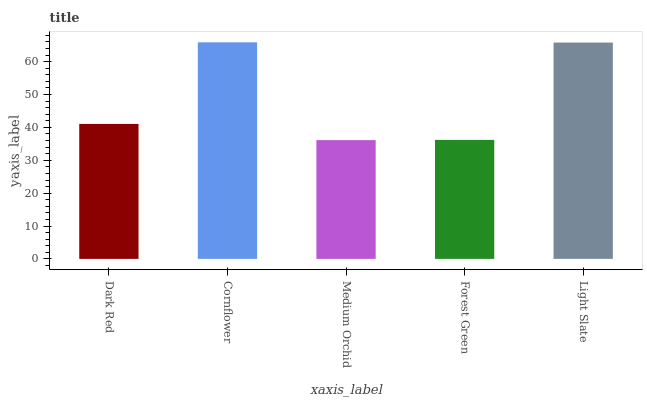Is Medium Orchid the minimum?
Answer yes or no. Yes. Is Cornflower the maximum?
Answer yes or no. Yes. Is Cornflower the minimum?
Answer yes or no. No. Is Medium Orchid the maximum?
Answer yes or no. No. Is Cornflower greater than Medium Orchid?
Answer yes or no. Yes. Is Medium Orchid less than Cornflower?
Answer yes or no. Yes. Is Medium Orchid greater than Cornflower?
Answer yes or no. No. Is Cornflower less than Medium Orchid?
Answer yes or no. No. Is Dark Red the high median?
Answer yes or no. Yes. Is Dark Red the low median?
Answer yes or no. Yes. Is Medium Orchid the high median?
Answer yes or no. No. Is Forest Green the low median?
Answer yes or no. No. 